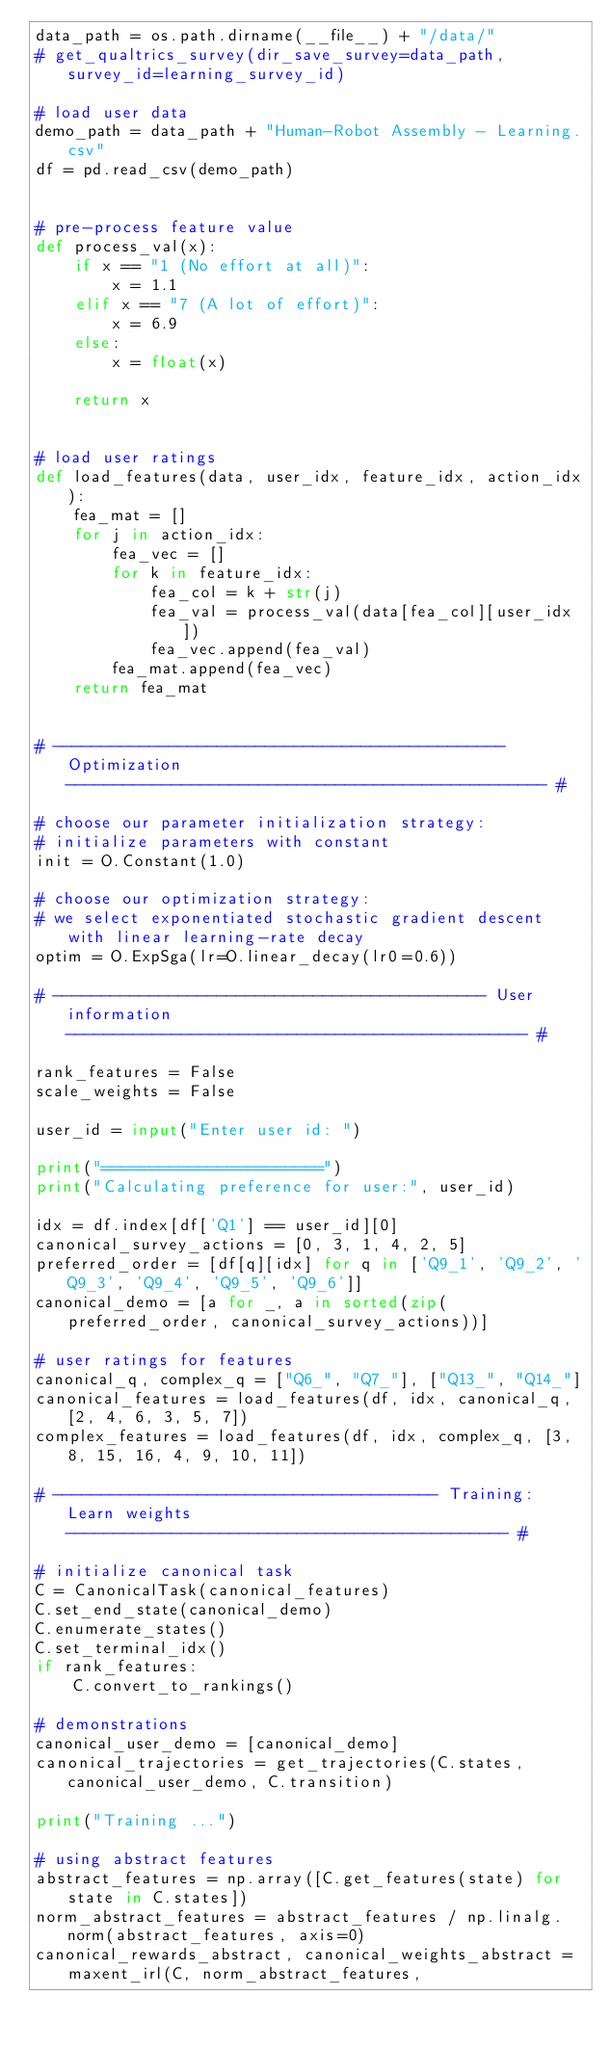Convert code to text. <code><loc_0><loc_0><loc_500><loc_500><_Python_>data_path = os.path.dirname(__file__) + "/data/"
# get_qualtrics_survey(dir_save_survey=data_path, survey_id=learning_survey_id)

# load user data
demo_path = data_path + "Human-Robot Assembly - Learning.csv"
df = pd.read_csv(demo_path)


# pre-process feature value
def process_val(x):
    if x == "1 (No effort at all)":
        x = 1.1
    elif x == "7 (A lot of effort)":
        x = 6.9
    else:
        x = float(x)

    return x


# load user ratings
def load_features(data, user_idx, feature_idx, action_idx):
    fea_mat = []
    for j in action_idx:
        fea_vec = []
        for k in feature_idx:
            fea_col = k + str(j)
            fea_val = process_val(data[fea_col][user_idx])
            fea_vec.append(fea_val)
        fea_mat.append(fea_vec)
    return fea_mat


# ----------------------------------------------- Optimization -------------------------------------------------- #

# choose our parameter initialization strategy:
# initialize parameters with constant
init = O.Constant(1.0)

# choose our optimization strategy:
# we select exponentiated stochastic gradient descent with linear learning-rate decay
optim = O.ExpSga(lr=O.linear_decay(lr0=0.6))

# --------------------------------------------- User information ------------------------------------------------ #

rank_features = False
scale_weights = False

user_id = input("Enter user id: ")

print("=======================")
print("Calculating preference for user:", user_id)

idx = df.index[df['Q1'] == user_id][0]
canonical_survey_actions = [0, 3, 1, 4, 2, 5]
preferred_order = [df[q][idx] for q in ['Q9_1', 'Q9_2', 'Q9_3', 'Q9_4', 'Q9_5', 'Q9_6']]
canonical_demo = [a for _, a in sorted(zip(preferred_order, canonical_survey_actions))]

# user ratings for features
canonical_q, complex_q = ["Q6_", "Q7_"], ["Q13_", "Q14_"] 
canonical_features = load_features(df, idx, canonical_q, [2, 4, 6, 3, 5, 7])
complex_features = load_features(df, idx, complex_q, [3, 8, 15, 16, 4, 9, 10, 11])

# ---------------------------------------- Training: Learn weights ---------------------------------------------- #

# initialize canonical task
C = CanonicalTask(canonical_features)
C.set_end_state(canonical_demo)
C.enumerate_states()
C.set_terminal_idx()
if rank_features:
    C.convert_to_rankings()

# demonstrations
canonical_user_demo = [canonical_demo]
canonical_trajectories = get_trajectories(C.states, canonical_user_demo, C.transition)

print("Training ...")

# using abstract features
abstract_features = np.array([C.get_features(state) for state in C.states])
norm_abstract_features = abstract_features / np.linalg.norm(abstract_features, axis=0)
canonical_rewards_abstract, canonical_weights_abstract = maxent_irl(C, norm_abstract_features,</code> 